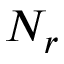<formula> <loc_0><loc_0><loc_500><loc_500>N _ { r }</formula> 